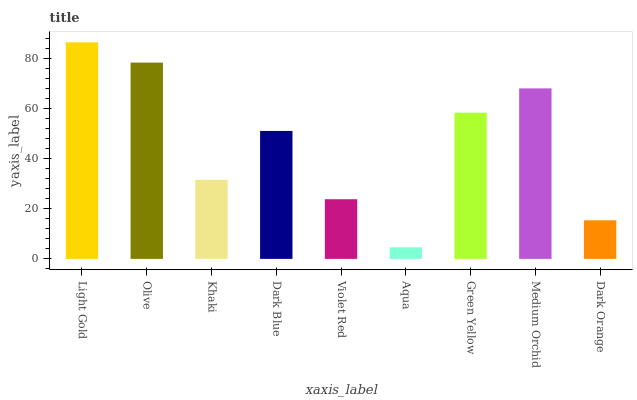Is Aqua the minimum?
Answer yes or no. Yes. Is Light Gold the maximum?
Answer yes or no. Yes. Is Olive the minimum?
Answer yes or no. No. Is Olive the maximum?
Answer yes or no. No. Is Light Gold greater than Olive?
Answer yes or no. Yes. Is Olive less than Light Gold?
Answer yes or no. Yes. Is Olive greater than Light Gold?
Answer yes or no. No. Is Light Gold less than Olive?
Answer yes or no. No. Is Dark Blue the high median?
Answer yes or no. Yes. Is Dark Blue the low median?
Answer yes or no. Yes. Is Khaki the high median?
Answer yes or no. No. Is Dark Orange the low median?
Answer yes or no. No. 